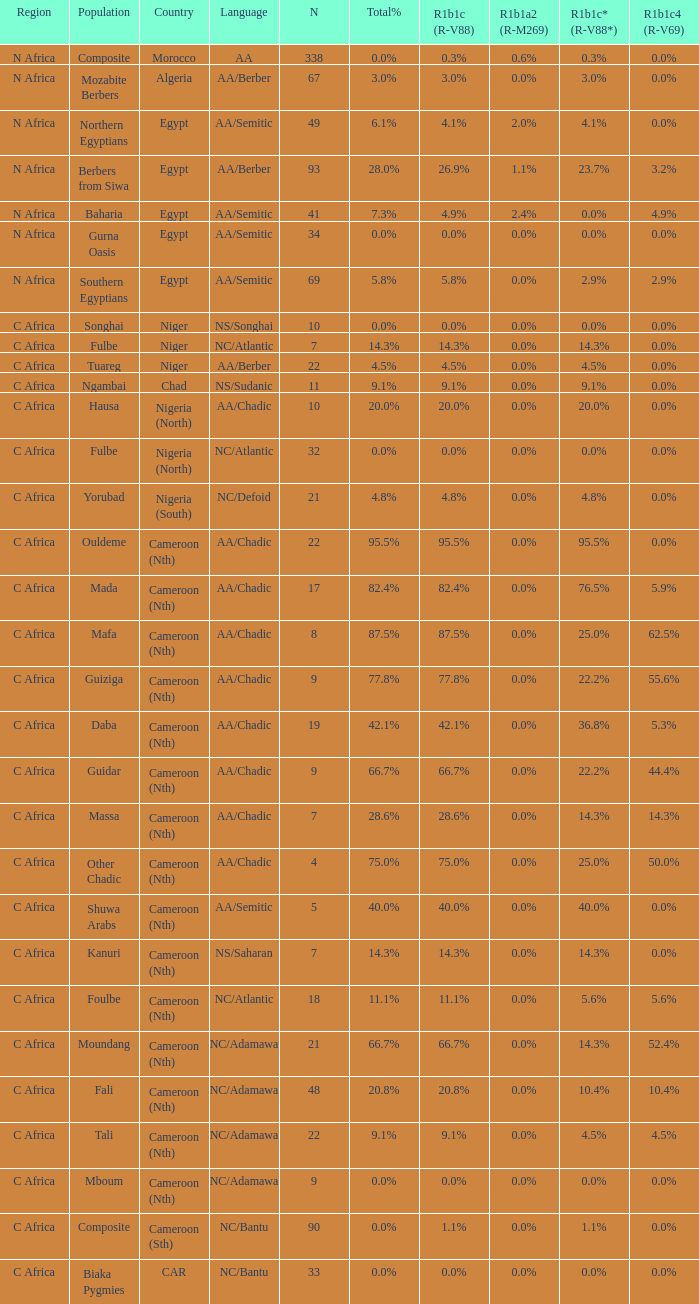6% r1b1a2 (r-m269)? 1.0. 